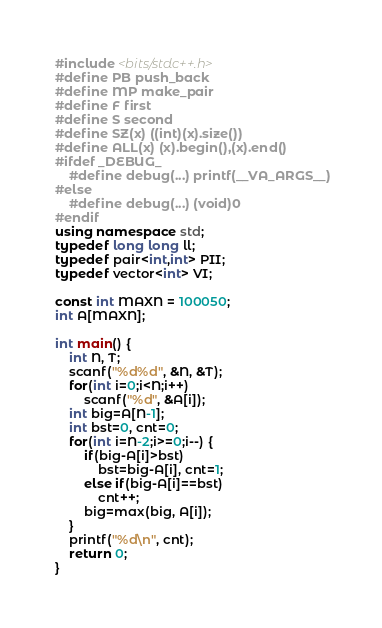Convert code to text. <code><loc_0><loc_0><loc_500><loc_500><_C++_>#include <bits/stdc++.h>
#define PB push_back
#define MP make_pair
#define F first
#define S second
#define SZ(x) ((int)(x).size())
#define ALL(x) (x).begin(),(x).end()
#ifdef _DEBUG_
	#define debug(...) printf(__VA_ARGS__)
#else
	#define debug(...) (void)0
#endif
using namespace std;
typedef long long ll;
typedef pair<int,int> PII;
typedef vector<int> VI;

const int MAXN = 100050;
int A[MAXN];

int main() {
	int N, T;
	scanf("%d%d", &N, &T);
	for(int i=0;i<N;i++)
		scanf("%d", &A[i]);
	int big=A[N-1];
	int bst=0, cnt=0;
	for(int i=N-2;i>=0;i--) {
		if(big-A[i]>bst)
			bst=big-A[i], cnt=1;
		else if(big-A[i]==bst)
			cnt++;
		big=max(big, A[i]);
	}
	printf("%d\n", cnt);
	return 0;
}
</code> 